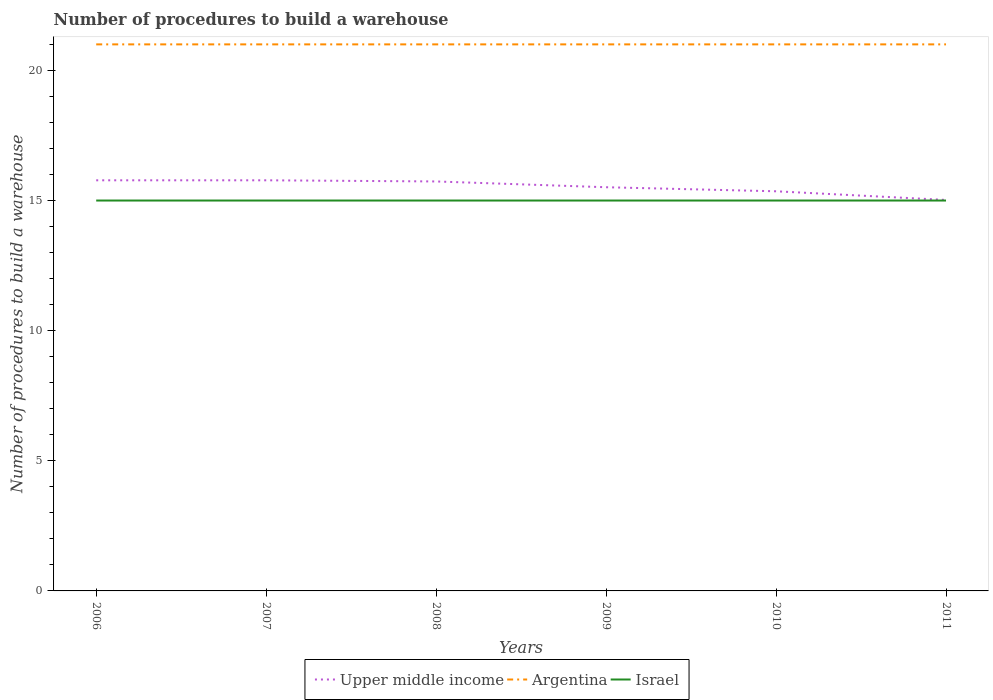Is the number of lines equal to the number of legend labels?
Ensure brevity in your answer.  Yes. Across all years, what is the maximum number of procedures to build a warehouse in in Argentina?
Provide a short and direct response. 21. Is the number of procedures to build a warehouse in in Israel strictly greater than the number of procedures to build a warehouse in in Upper middle income over the years?
Offer a terse response. Yes. How many lines are there?
Offer a terse response. 3. How many years are there in the graph?
Your answer should be compact. 6. What is the difference between two consecutive major ticks on the Y-axis?
Provide a succinct answer. 5. Where does the legend appear in the graph?
Ensure brevity in your answer.  Bottom center. What is the title of the graph?
Offer a very short reply. Number of procedures to build a warehouse. Does "Namibia" appear as one of the legend labels in the graph?
Provide a short and direct response. No. What is the label or title of the X-axis?
Provide a succinct answer. Years. What is the label or title of the Y-axis?
Offer a terse response. Number of procedures to build a warehouse. What is the Number of procedures to build a warehouse of Upper middle income in 2006?
Keep it short and to the point. 15.78. What is the Number of procedures to build a warehouse in Argentina in 2006?
Provide a short and direct response. 21. What is the Number of procedures to build a warehouse in Upper middle income in 2007?
Provide a succinct answer. 15.78. What is the Number of procedures to build a warehouse in Argentina in 2007?
Provide a short and direct response. 21. What is the Number of procedures to build a warehouse in Israel in 2007?
Ensure brevity in your answer.  15. What is the Number of procedures to build a warehouse of Upper middle income in 2008?
Provide a short and direct response. 15.73. What is the Number of procedures to build a warehouse of Argentina in 2008?
Provide a short and direct response. 21. What is the Number of procedures to build a warehouse of Israel in 2008?
Give a very brief answer. 15. What is the Number of procedures to build a warehouse of Upper middle income in 2009?
Your response must be concise. 15.51. What is the Number of procedures to build a warehouse in Israel in 2009?
Offer a terse response. 15. What is the Number of procedures to build a warehouse in Upper middle income in 2010?
Give a very brief answer. 15.36. What is the Number of procedures to build a warehouse of Argentina in 2010?
Your answer should be very brief. 21. What is the Number of procedures to build a warehouse in Israel in 2010?
Your answer should be compact. 15. What is the Number of procedures to build a warehouse in Upper middle income in 2011?
Give a very brief answer. 15.02. What is the Number of procedures to build a warehouse in Argentina in 2011?
Make the answer very short. 21. Across all years, what is the maximum Number of procedures to build a warehouse in Upper middle income?
Offer a terse response. 15.78. Across all years, what is the minimum Number of procedures to build a warehouse of Upper middle income?
Offer a very short reply. 15.02. Across all years, what is the minimum Number of procedures to build a warehouse in Argentina?
Make the answer very short. 21. What is the total Number of procedures to build a warehouse of Upper middle income in the graph?
Provide a succinct answer. 93.18. What is the total Number of procedures to build a warehouse in Argentina in the graph?
Offer a terse response. 126. What is the difference between the Number of procedures to build a warehouse in Argentina in 2006 and that in 2007?
Offer a terse response. 0. What is the difference between the Number of procedures to build a warehouse of Israel in 2006 and that in 2007?
Offer a terse response. 0. What is the difference between the Number of procedures to build a warehouse in Upper middle income in 2006 and that in 2008?
Give a very brief answer. 0.04. What is the difference between the Number of procedures to build a warehouse of Israel in 2006 and that in 2008?
Your response must be concise. 0. What is the difference between the Number of procedures to build a warehouse in Upper middle income in 2006 and that in 2009?
Your answer should be compact. 0.27. What is the difference between the Number of procedures to build a warehouse in Israel in 2006 and that in 2009?
Keep it short and to the point. 0. What is the difference between the Number of procedures to build a warehouse in Upper middle income in 2006 and that in 2010?
Provide a succinct answer. 0.42. What is the difference between the Number of procedures to build a warehouse in Argentina in 2006 and that in 2010?
Offer a terse response. 0. What is the difference between the Number of procedures to build a warehouse of Israel in 2006 and that in 2010?
Make the answer very short. 0. What is the difference between the Number of procedures to build a warehouse in Upper middle income in 2006 and that in 2011?
Provide a succinct answer. 0.76. What is the difference between the Number of procedures to build a warehouse in Argentina in 2006 and that in 2011?
Make the answer very short. 0. What is the difference between the Number of procedures to build a warehouse of Upper middle income in 2007 and that in 2008?
Give a very brief answer. 0.04. What is the difference between the Number of procedures to build a warehouse of Argentina in 2007 and that in 2008?
Offer a very short reply. 0. What is the difference between the Number of procedures to build a warehouse in Upper middle income in 2007 and that in 2009?
Offer a very short reply. 0.27. What is the difference between the Number of procedures to build a warehouse of Upper middle income in 2007 and that in 2010?
Your response must be concise. 0.42. What is the difference between the Number of procedures to build a warehouse of Argentina in 2007 and that in 2010?
Keep it short and to the point. 0. What is the difference between the Number of procedures to build a warehouse in Israel in 2007 and that in 2010?
Ensure brevity in your answer.  0. What is the difference between the Number of procedures to build a warehouse in Upper middle income in 2007 and that in 2011?
Ensure brevity in your answer.  0.76. What is the difference between the Number of procedures to build a warehouse in Argentina in 2007 and that in 2011?
Keep it short and to the point. 0. What is the difference between the Number of procedures to build a warehouse in Israel in 2007 and that in 2011?
Keep it short and to the point. 0. What is the difference between the Number of procedures to build a warehouse in Upper middle income in 2008 and that in 2009?
Your answer should be compact. 0.22. What is the difference between the Number of procedures to build a warehouse of Argentina in 2008 and that in 2009?
Provide a short and direct response. 0. What is the difference between the Number of procedures to build a warehouse in Upper middle income in 2008 and that in 2010?
Your answer should be compact. 0.38. What is the difference between the Number of procedures to build a warehouse in Argentina in 2008 and that in 2010?
Offer a terse response. 0. What is the difference between the Number of procedures to build a warehouse in Israel in 2008 and that in 2010?
Offer a terse response. 0. What is the difference between the Number of procedures to build a warehouse of Upper middle income in 2008 and that in 2011?
Provide a succinct answer. 0.71. What is the difference between the Number of procedures to build a warehouse in Israel in 2008 and that in 2011?
Offer a very short reply. 0. What is the difference between the Number of procedures to build a warehouse in Upper middle income in 2009 and that in 2010?
Provide a short and direct response. 0.16. What is the difference between the Number of procedures to build a warehouse of Israel in 2009 and that in 2010?
Make the answer very short. 0. What is the difference between the Number of procedures to build a warehouse of Upper middle income in 2009 and that in 2011?
Make the answer very short. 0.49. What is the difference between the Number of procedures to build a warehouse in Israel in 2009 and that in 2011?
Offer a very short reply. 0. What is the difference between the Number of procedures to build a warehouse in Upper middle income in 2010 and that in 2011?
Your answer should be compact. 0.33. What is the difference between the Number of procedures to build a warehouse in Argentina in 2010 and that in 2011?
Ensure brevity in your answer.  0. What is the difference between the Number of procedures to build a warehouse of Upper middle income in 2006 and the Number of procedures to build a warehouse of Argentina in 2007?
Provide a short and direct response. -5.22. What is the difference between the Number of procedures to build a warehouse of Upper middle income in 2006 and the Number of procedures to build a warehouse of Israel in 2007?
Your response must be concise. 0.78. What is the difference between the Number of procedures to build a warehouse of Argentina in 2006 and the Number of procedures to build a warehouse of Israel in 2007?
Your answer should be compact. 6. What is the difference between the Number of procedures to build a warehouse in Upper middle income in 2006 and the Number of procedures to build a warehouse in Argentina in 2008?
Ensure brevity in your answer.  -5.22. What is the difference between the Number of procedures to build a warehouse in Upper middle income in 2006 and the Number of procedures to build a warehouse in Israel in 2008?
Your answer should be compact. 0.78. What is the difference between the Number of procedures to build a warehouse in Argentina in 2006 and the Number of procedures to build a warehouse in Israel in 2008?
Offer a terse response. 6. What is the difference between the Number of procedures to build a warehouse of Upper middle income in 2006 and the Number of procedures to build a warehouse of Argentina in 2009?
Your answer should be very brief. -5.22. What is the difference between the Number of procedures to build a warehouse of Argentina in 2006 and the Number of procedures to build a warehouse of Israel in 2009?
Make the answer very short. 6. What is the difference between the Number of procedures to build a warehouse in Upper middle income in 2006 and the Number of procedures to build a warehouse in Argentina in 2010?
Your answer should be compact. -5.22. What is the difference between the Number of procedures to build a warehouse of Upper middle income in 2006 and the Number of procedures to build a warehouse of Argentina in 2011?
Keep it short and to the point. -5.22. What is the difference between the Number of procedures to build a warehouse of Upper middle income in 2007 and the Number of procedures to build a warehouse of Argentina in 2008?
Provide a short and direct response. -5.22. What is the difference between the Number of procedures to build a warehouse in Upper middle income in 2007 and the Number of procedures to build a warehouse in Israel in 2008?
Keep it short and to the point. 0.78. What is the difference between the Number of procedures to build a warehouse in Upper middle income in 2007 and the Number of procedures to build a warehouse in Argentina in 2009?
Make the answer very short. -5.22. What is the difference between the Number of procedures to build a warehouse of Argentina in 2007 and the Number of procedures to build a warehouse of Israel in 2009?
Ensure brevity in your answer.  6. What is the difference between the Number of procedures to build a warehouse of Upper middle income in 2007 and the Number of procedures to build a warehouse of Argentina in 2010?
Provide a short and direct response. -5.22. What is the difference between the Number of procedures to build a warehouse in Upper middle income in 2007 and the Number of procedures to build a warehouse in Israel in 2010?
Ensure brevity in your answer.  0.78. What is the difference between the Number of procedures to build a warehouse in Argentina in 2007 and the Number of procedures to build a warehouse in Israel in 2010?
Your answer should be compact. 6. What is the difference between the Number of procedures to build a warehouse in Upper middle income in 2007 and the Number of procedures to build a warehouse in Argentina in 2011?
Offer a terse response. -5.22. What is the difference between the Number of procedures to build a warehouse of Upper middle income in 2008 and the Number of procedures to build a warehouse of Argentina in 2009?
Your answer should be compact. -5.27. What is the difference between the Number of procedures to build a warehouse in Upper middle income in 2008 and the Number of procedures to build a warehouse in Israel in 2009?
Ensure brevity in your answer.  0.73. What is the difference between the Number of procedures to build a warehouse of Argentina in 2008 and the Number of procedures to build a warehouse of Israel in 2009?
Your answer should be very brief. 6. What is the difference between the Number of procedures to build a warehouse of Upper middle income in 2008 and the Number of procedures to build a warehouse of Argentina in 2010?
Provide a short and direct response. -5.27. What is the difference between the Number of procedures to build a warehouse in Upper middle income in 2008 and the Number of procedures to build a warehouse in Israel in 2010?
Give a very brief answer. 0.73. What is the difference between the Number of procedures to build a warehouse in Upper middle income in 2008 and the Number of procedures to build a warehouse in Argentina in 2011?
Your answer should be very brief. -5.27. What is the difference between the Number of procedures to build a warehouse of Upper middle income in 2008 and the Number of procedures to build a warehouse of Israel in 2011?
Your response must be concise. 0.73. What is the difference between the Number of procedures to build a warehouse of Upper middle income in 2009 and the Number of procedures to build a warehouse of Argentina in 2010?
Provide a succinct answer. -5.49. What is the difference between the Number of procedures to build a warehouse of Upper middle income in 2009 and the Number of procedures to build a warehouse of Israel in 2010?
Your answer should be compact. 0.51. What is the difference between the Number of procedures to build a warehouse of Upper middle income in 2009 and the Number of procedures to build a warehouse of Argentina in 2011?
Offer a terse response. -5.49. What is the difference between the Number of procedures to build a warehouse in Upper middle income in 2009 and the Number of procedures to build a warehouse in Israel in 2011?
Keep it short and to the point. 0.51. What is the difference between the Number of procedures to build a warehouse in Upper middle income in 2010 and the Number of procedures to build a warehouse in Argentina in 2011?
Provide a short and direct response. -5.64. What is the difference between the Number of procedures to build a warehouse in Upper middle income in 2010 and the Number of procedures to build a warehouse in Israel in 2011?
Your answer should be compact. 0.36. What is the difference between the Number of procedures to build a warehouse in Argentina in 2010 and the Number of procedures to build a warehouse in Israel in 2011?
Give a very brief answer. 6. What is the average Number of procedures to build a warehouse of Upper middle income per year?
Provide a succinct answer. 15.53. In the year 2006, what is the difference between the Number of procedures to build a warehouse in Upper middle income and Number of procedures to build a warehouse in Argentina?
Make the answer very short. -5.22. In the year 2006, what is the difference between the Number of procedures to build a warehouse of Upper middle income and Number of procedures to build a warehouse of Israel?
Give a very brief answer. 0.78. In the year 2006, what is the difference between the Number of procedures to build a warehouse in Argentina and Number of procedures to build a warehouse in Israel?
Provide a short and direct response. 6. In the year 2007, what is the difference between the Number of procedures to build a warehouse of Upper middle income and Number of procedures to build a warehouse of Argentina?
Give a very brief answer. -5.22. In the year 2007, what is the difference between the Number of procedures to build a warehouse in Upper middle income and Number of procedures to build a warehouse in Israel?
Offer a terse response. 0.78. In the year 2007, what is the difference between the Number of procedures to build a warehouse in Argentina and Number of procedures to build a warehouse in Israel?
Offer a terse response. 6. In the year 2008, what is the difference between the Number of procedures to build a warehouse of Upper middle income and Number of procedures to build a warehouse of Argentina?
Provide a succinct answer. -5.27. In the year 2008, what is the difference between the Number of procedures to build a warehouse of Upper middle income and Number of procedures to build a warehouse of Israel?
Provide a succinct answer. 0.73. In the year 2008, what is the difference between the Number of procedures to build a warehouse of Argentina and Number of procedures to build a warehouse of Israel?
Your response must be concise. 6. In the year 2009, what is the difference between the Number of procedures to build a warehouse in Upper middle income and Number of procedures to build a warehouse in Argentina?
Provide a succinct answer. -5.49. In the year 2009, what is the difference between the Number of procedures to build a warehouse in Upper middle income and Number of procedures to build a warehouse in Israel?
Your answer should be very brief. 0.51. In the year 2010, what is the difference between the Number of procedures to build a warehouse in Upper middle income and Number of procedures to build a warehouse in Argentina?
Make the answer very short. -5.64. In the year 2010, what is the difference between the Number of procedures to build a warehouse in Upper middle income and Number of procedures to build a warehouse in Israel?
Provide a short and direct response. 0.36. In the year 2010, what is the difference between the Number of procedures to build a warehouse of Argentina and Number of procedures to build a warehouse of Israel?
Keep it short and to the point. 6. In the year 2011, what is the difference between the Number of procedures to build a warehouse of Upper middle income and Number of procedures to build a warehouse of Argentina?
Keep it short and to the point. -5.98. In the year 2011, what is the difference between the Number of procedures to build a warehouse in Upper middle income and Number of procedures to build a warehouse in Israel?
Make the answer very short. 0.02. In the year 2011, what is the difference between the Number of procedures to build a warehouse in Argentina and Number of procedures to build a warehouse in Israel?
Give a very brief answer. 6. What is the ratio of the Number of procedures to build a warehouse of Argentina in 2006 to that in 2007?
Your response must be concise. 1. What is the ratio of the Number of procedures to build a warehouse of Israel in 2006 to that in 2008?
Give a very brief answer. 1. What is the ratio of the Number of procedures to build a warehouse in Upper middle income in 2006 to that in 2009?
Keep it short and to the point. 1.02. What is the ratio of the Number of procedures to build a warehouse in Argentina in 2006 to that in 2009?
Make the answer very short. 1. What is the ratio of the Number of procedures to build a warehouse in Upper middle income in 2006 to that in 2010?
Make the answer very short. 1.03. What is the ratio of the Number of procedures to build a warehouse of Israel in 2006 to that in 2010?
Your response must be concise. 1. What is the ratio of the Number of procedures to build a warehouse in Upper middle income in 2006 to that in 2011?
Provide a short and direct response. 1.05. What is the ratio of the Number of procedures to build a warehouse of Argentina in 2006 to that in 2011?
Offer a very short reply. 1. What is the ratio of the Number of procedures to build a warehouse of Upper middle income in 2007 to that in 2008?
Provide a short and direct response. 1. What is the ratio of the Number of procedures to build a warehouse of Israel in 2007 to that in 2008?
Offer a terse response. 1. What is the ratio of the Number of procedures to build a warehouse of Upper middle income in 2007 to that in 2009?
Your answer should be compact. 1.02. What is the ratio of the Number of procedures to build a warehouse of Upper middle income in 2007 to that in 2010?
Your answer should be compact. 1.03. What is the ratio of the Number of procedures to build a warehouse in Israel in 2007 to that in 2010?
Keep it short and to the point. 1. What is the ratio of the Number of procedures to build a warehouse in Upper middle income in 2007 to that in 2011?
Your answer should be very brief. 1.05. What is the ratio of the Number of procedures to build a warehouse of Argentina in 2007 to that in 2011?
Offer a very short reply. 1. What is the ratio of the Number of procedures to build a warehouse in Upper middle income in 2008 to that in 2009?
Provide a succinct answer. 1.01. What is the ratio of the Number of procedures to build a warehouse in Israel in 2008 to that in 2009?
Your response must be concise. 1. What is the ratio of the Number of procedures to build a warehouse in Upper middle income in 2008 to that in 2010?
Offer a terse response. 1.02. What is the ratio of the Number of procedures to build a warehouse in Upper middle income in 2008 to that in 2011?
Provide a succinct answer. 1.05. What is the ratio of the Number of procedures to build a warehouse in Argentina in 2008 to that in 2011?
Keep it short and to the point. 1. What is the ratio of the Number of procedures to build a warehouse in Argentina in 2009 to that in 2010?
Make the answer very short. 1. What is the ratio of the Number of procedures to build a warehouse of Upper middle income in 2009 to that in 2011?
Your answer should be very brief. 1.03. What is the ratio of the Number of procedures to build a warehouse in Israel in 2009 to that in 2011?
Provide a short and direct response. 1. What is the ratio of the Number of procedures to build a warehouse in Upper middle income in 2010 to that in 2011?
Your answer should be compact. 1.02. What is the difference between the highest and the lowest Number of procedures to build a warehouse of Upper middle income?
Your response must be concise. 0.76. 